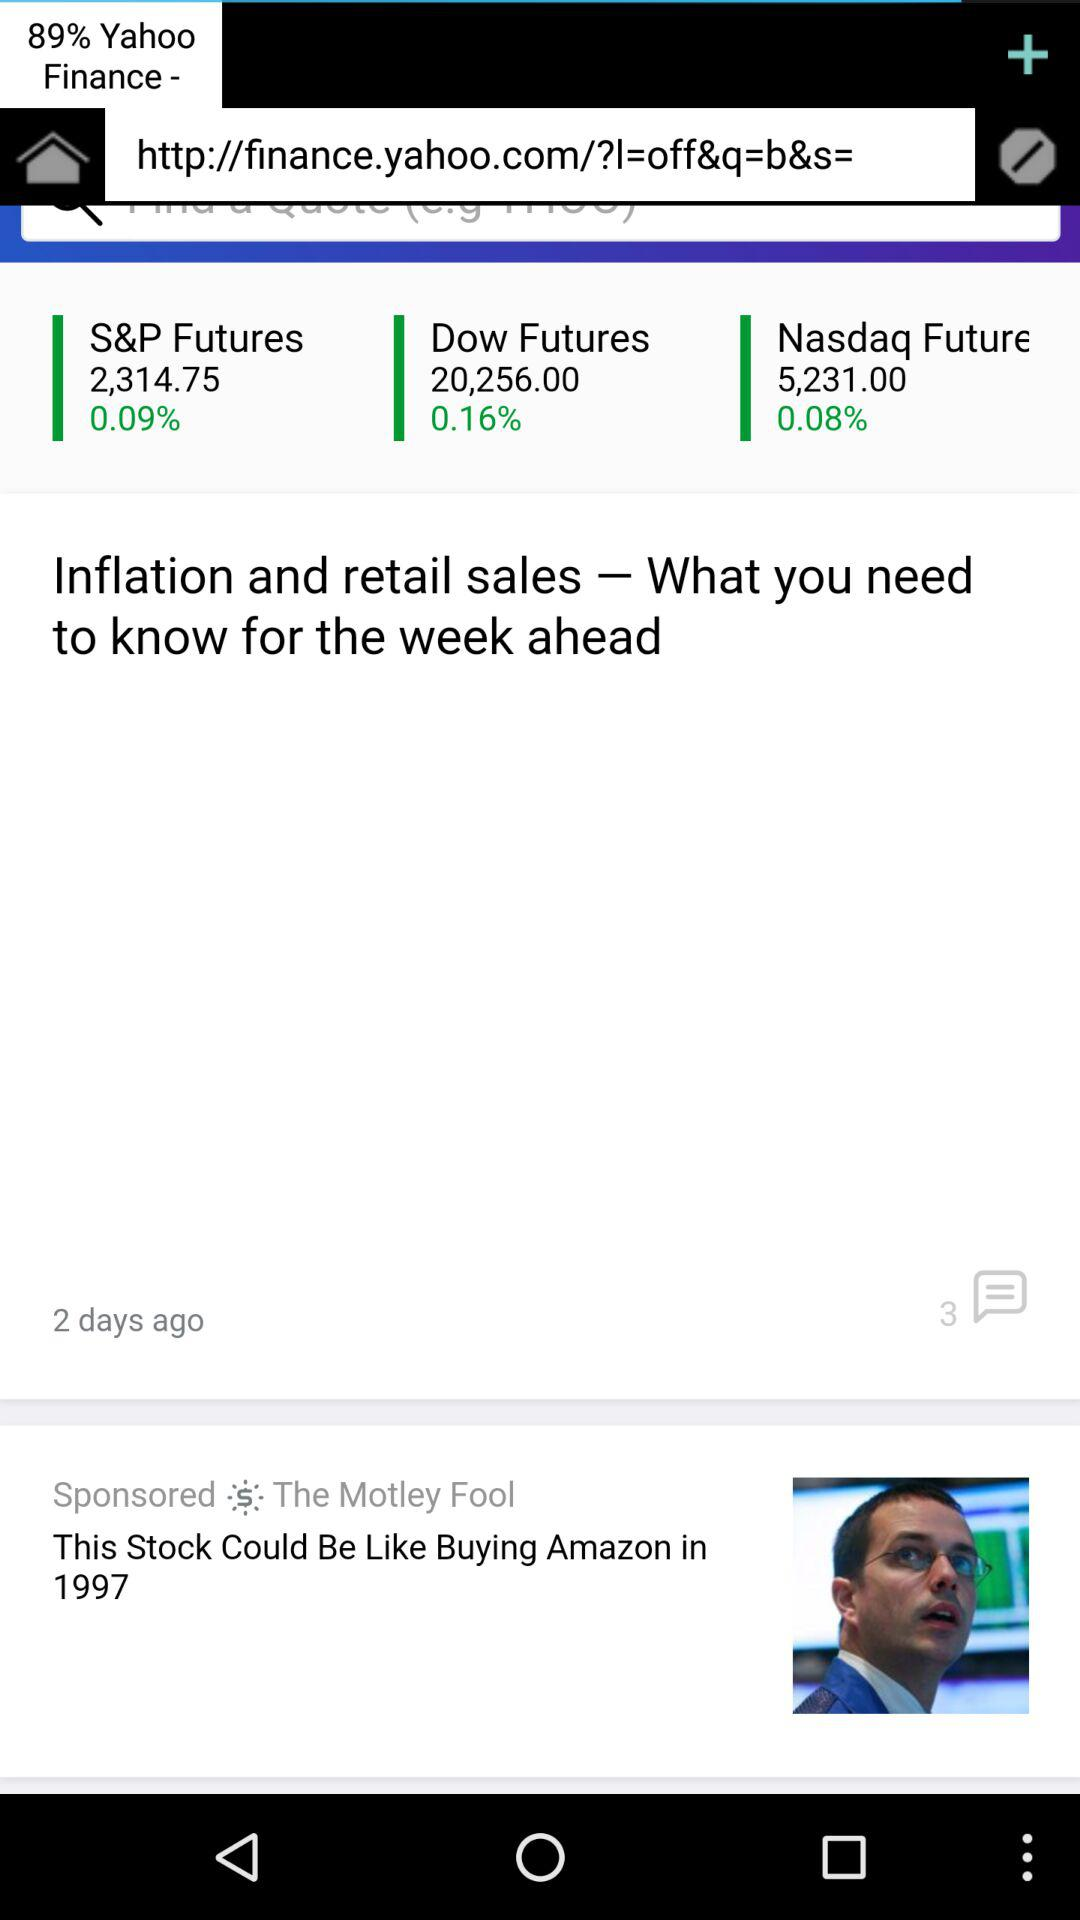How many days ago was the article "Inflation and retail sales—What you need to know for the week ahead" posted? The article was posted 2 days ago. 